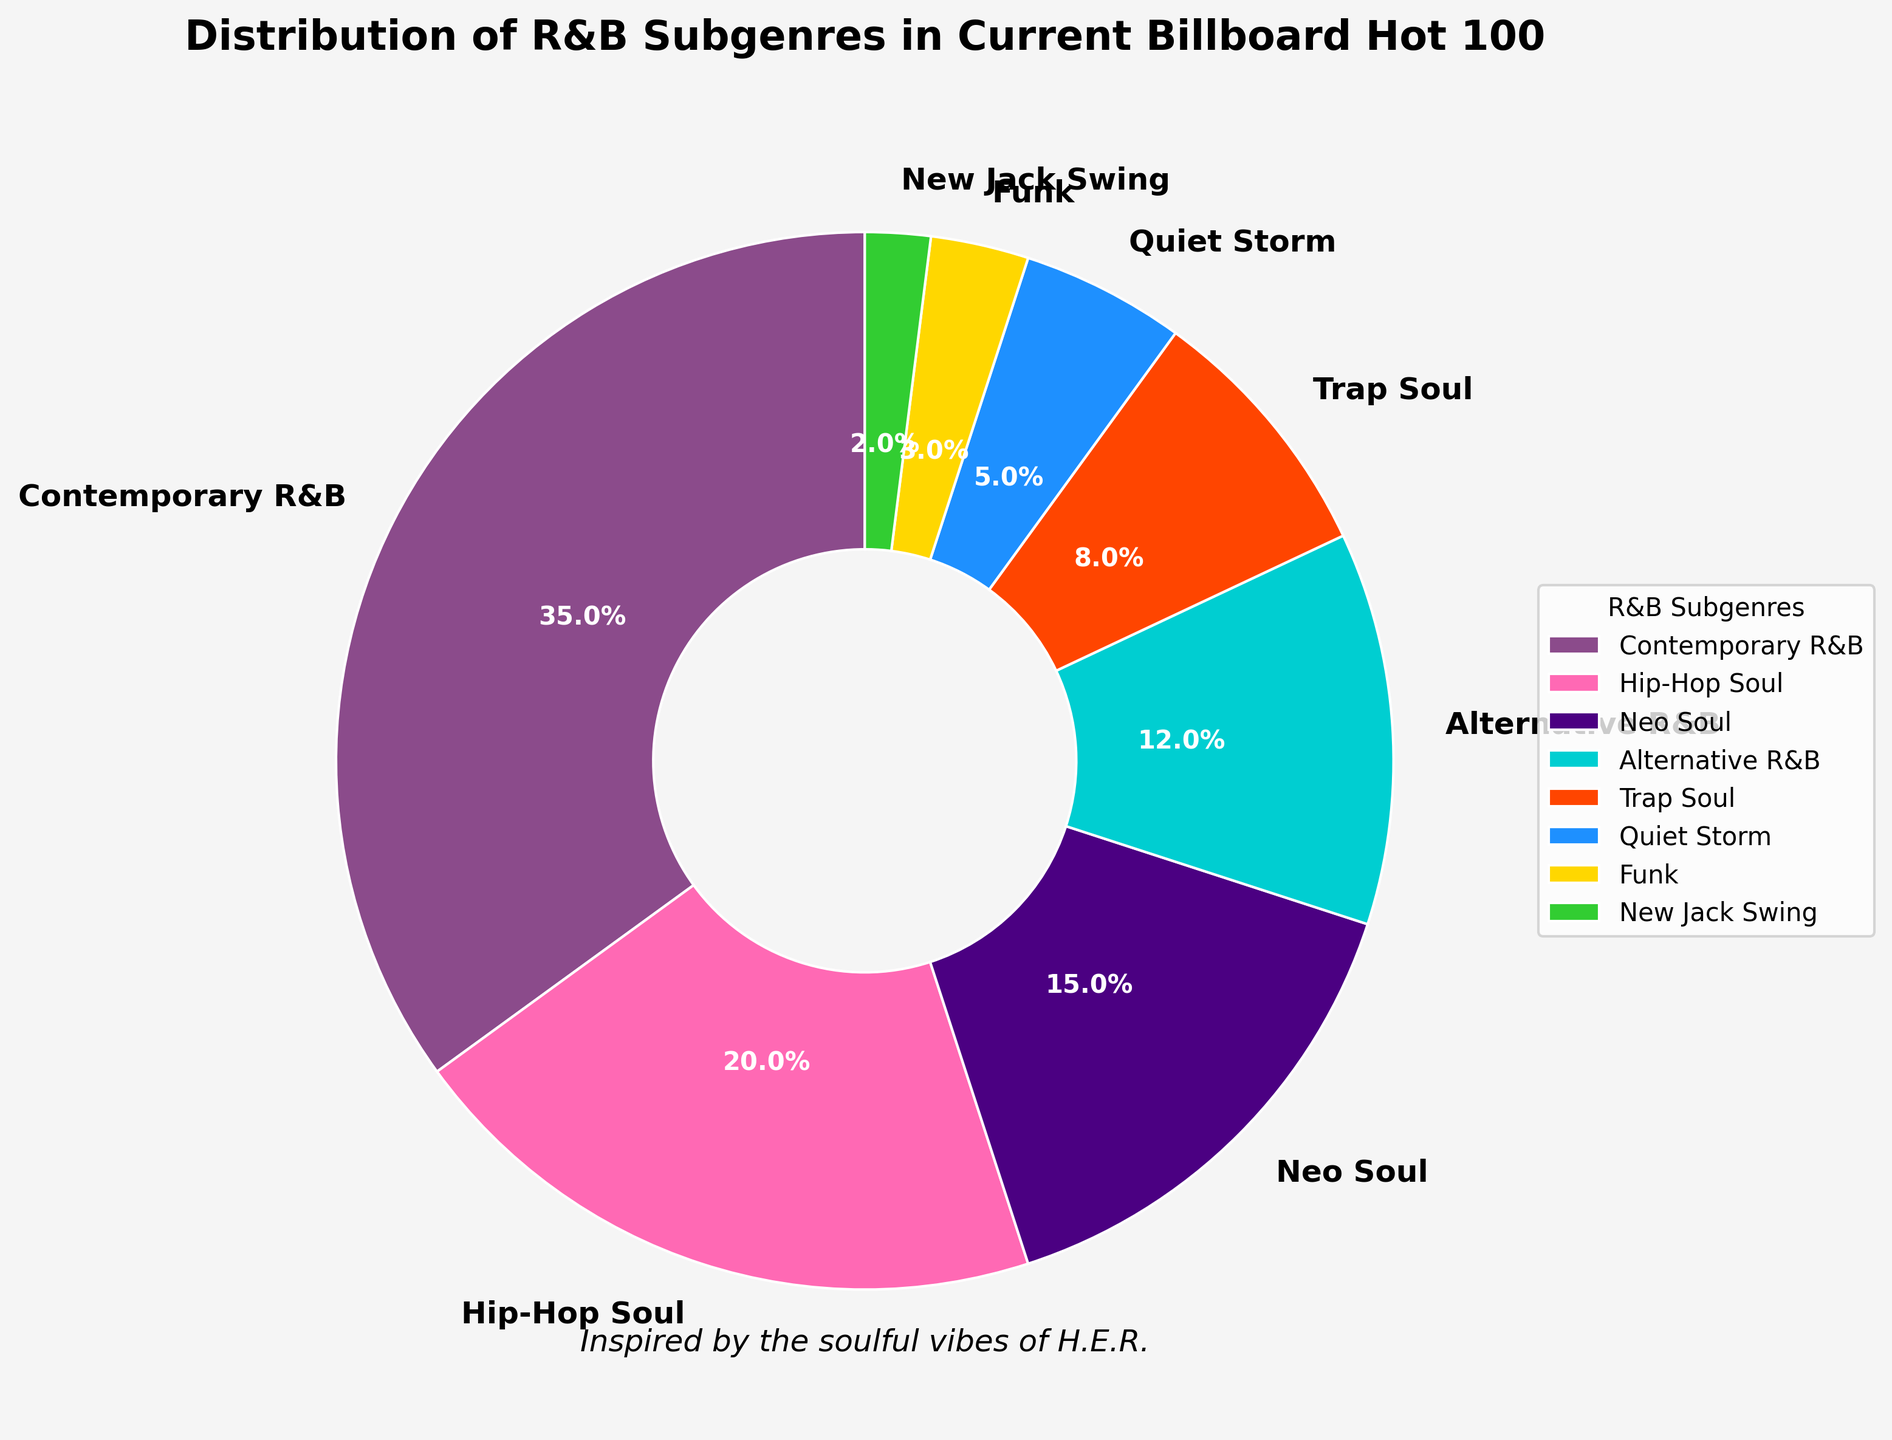Which subgenre has the largest percentage distribution? The figure shows the distribution of percentages for each subgenre. The largest slice or section of the pie chart is "Contemporary R&B" with 35%.
Answer: Contemporary R&B What is the combined percentage of Hip-Hop Soul and Neo Soul? From the pie chart, Hip-Hop Soul is 20% and Neo Soul is 15%. Adding these together: 20 + 15 = 35%.
Answer: 35% Which two subgenres together make up exactly 20%? The pie chart shows Quiet Storm at 5% and Trap Soul at 8%, and New Jack Swing at 2%. Adding these together: 8 + 5 + 2 = 15%. Adding the Funk subgenre: 5 + 3 + 2 = 10% So none make up 20%. Therefore, just identify together combined percentages: none.
Answer: none How much larger is Contemporary R&B than Alternative R&B in percentage? From the chart, Contemporary R&B is 35% while Alternative R&B is 12%. Subtracting these values gives: 35 - 12 = 23%.
Answer: 23% What percentage does the Quiet Storm subgenre cover in the chart? The pie chart section corresponding to "Quiet Storm" is labeled 5%.
Answer: 5% Which subgenre has the smallest percentage distribution and what is that percentage? The smallest slice in the pie chart corresponds to "New Jack Swing" with a percentage of 2%.
Answer: New Jack Swing, 2% Compare the combined percentage of the least three represented subgenres to the percentage of Alternative R&B. Which is larger? The least three represented subgenres are Funk (3%), New Jack Swing (2%), and Quiet Storm (5%). Their combined percentage is 3 + 2 + 5 = 10%. Alternative R&B is 12%. Alternative R&B's percentage is larger.
Answer: Alternative R&B What is the difference in percentage between Hip-Hop Soul and Trap Soul? From the pie chart, Hip-Hop Soul is 20% and Trap Soul is 8%. The difference is 20 - 8 = 12%.
Answer: 12% Which subgenre comes third in the percentage distribution? The third largest section in the pie chart is "Neo Soul" at 15%, following Contemporary R&B at 35% and Hip-Hop Soul at 20%.
Answer: Neo Soul What percentage of the Billboard Hot 100 chart is made up by subgenres other than Contemporary R&B and Hip-Hop Soul? Contemporary R&B and Hip-Hop Soul together make up 35% + 20% = 55%. Subtracting this from 100% gives: 100 - 55 = 45%.
Answer: 45% 